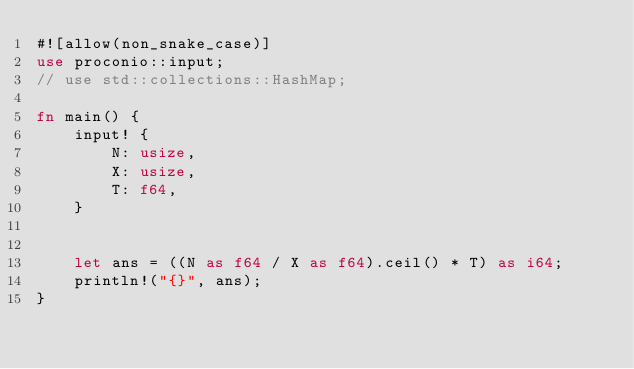Convert code to text. <code><loc_0><loc_0><loc_500><loc_500><_Rust_>#![allow(non_snake_case)]
use proconio::input;
// use std::collections::HashMap;

fn main() {
    input! {
        N: usize,
        X: usize,
        T: f64,
    }


    let ans = ((N as f64 / X as f64).ceil() * T) as i64;
    println!("{}", ans);
}
</code> 